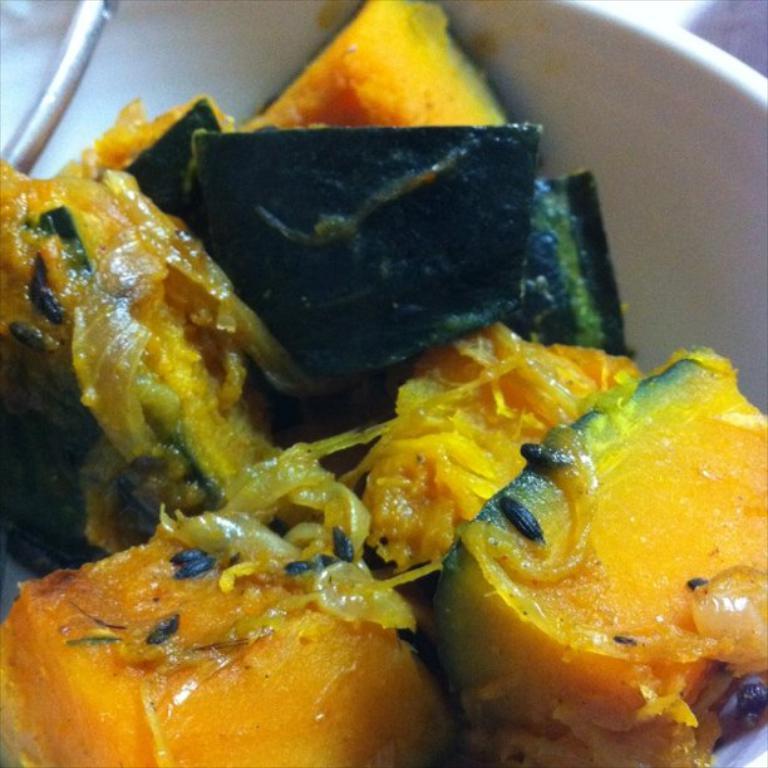In one or two sentences, can you explain what this image depicts? In this image we see a food item in a bowl and in the top left we can see a metal. 